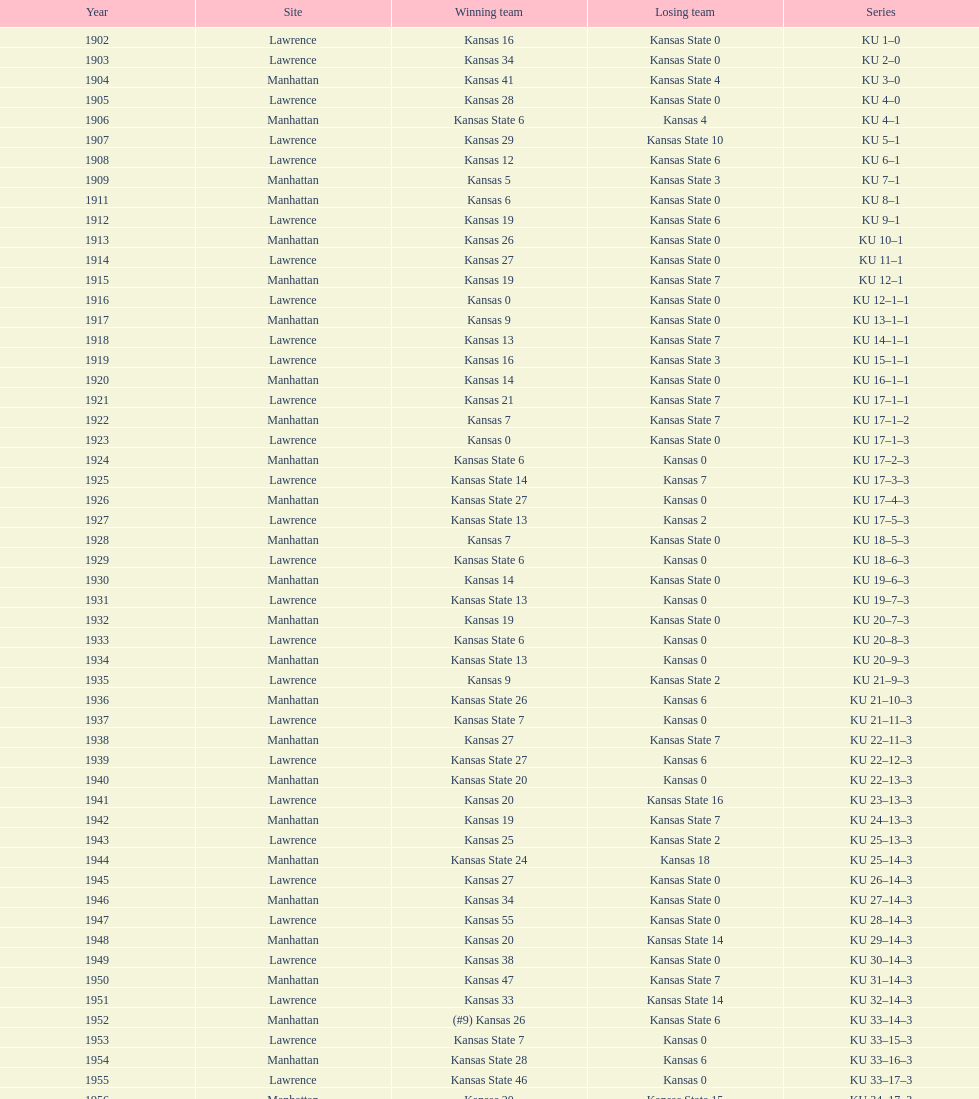When was the last time kansas state lost with 0 points in manhattan? 1964. 